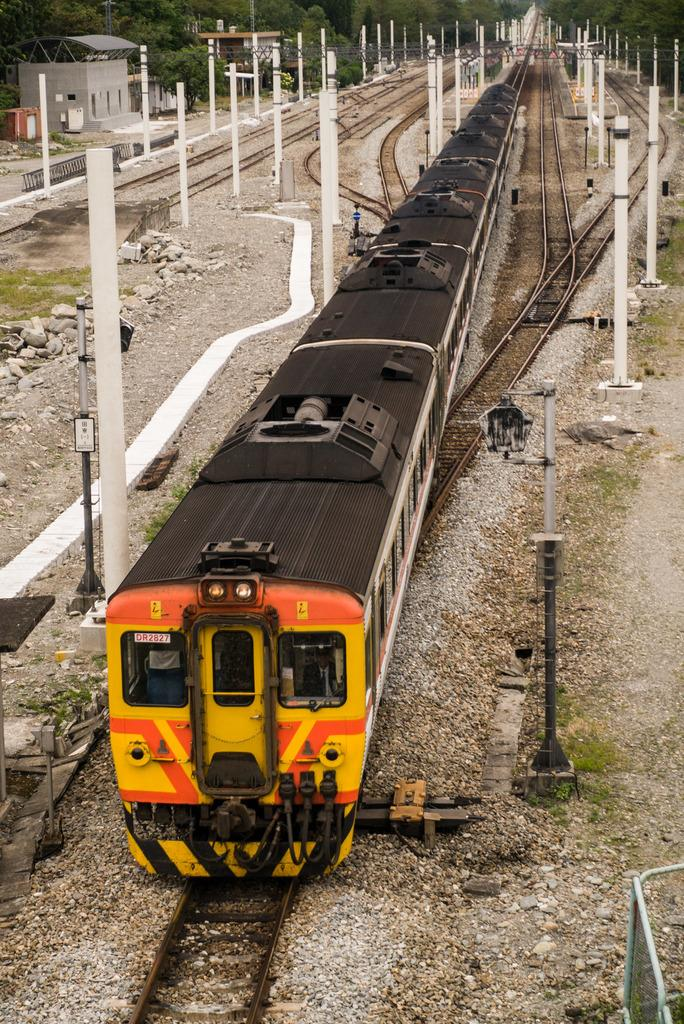What type of transportation infrastructure is visible in the image? There are railway tracks in the image. What is traveling on the railway tracks? There is a train on the railway tracks. What structures can be seen alongside the railway tracks? There are poles visible in the image. What type of natural environment is present in the image? There are trees and grass in the image. What type of building is present in the image? There is a shack in the image. What color is the toe of the person driving the train in the image? There is no person driving the train visible in the image, and therefore no toe can be observed. 